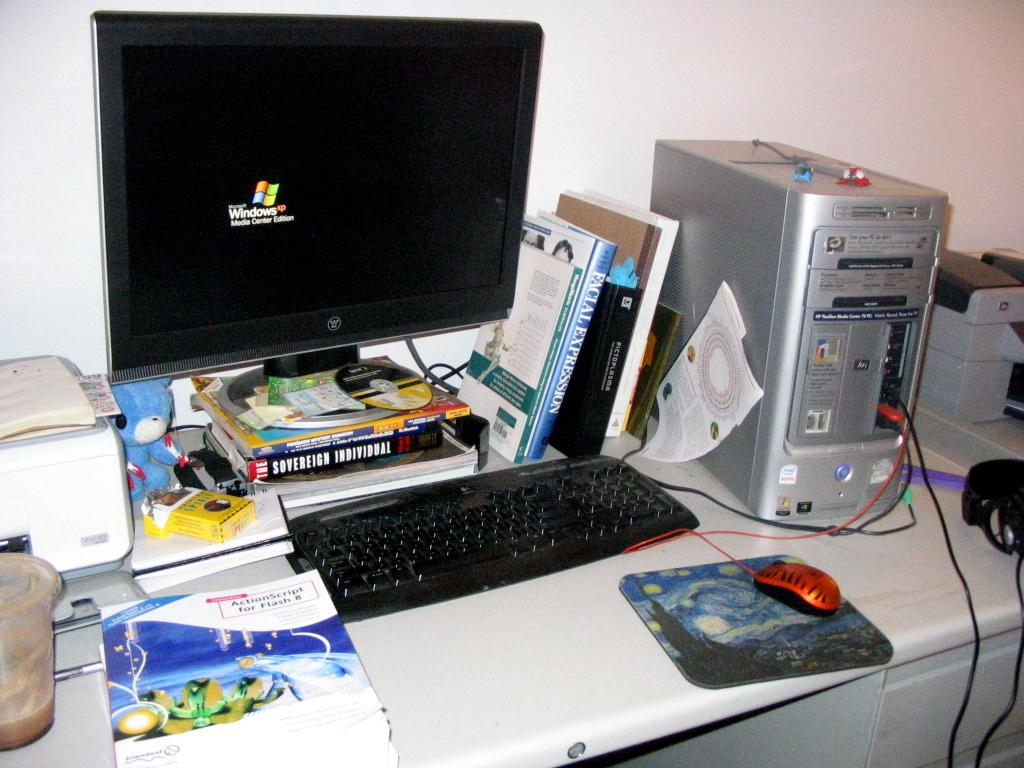<image>
Provide a brief description of the given image. A work station with Westinghouse computer and tower, keyboard and books and American Spirit cigarettes on it. 